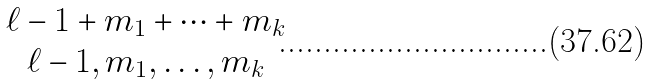<formula> <loc_0><loc_0><loc_500><loc_500>\begin{matrix} \ell - 1 + m _ { 1 } + \cdots + m _ { k } \\ \ell - 1 , m _ { 1 } , \dots , m _ { k } \end{matrix}</formula> 